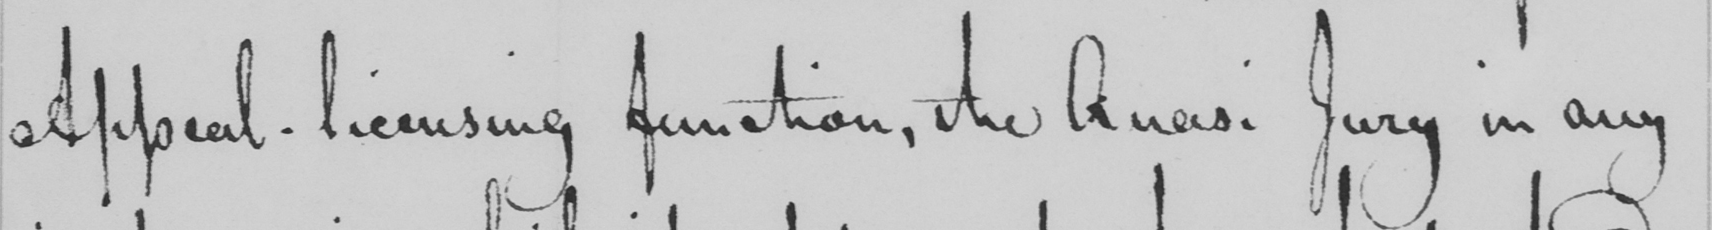What does this handwritten line say? Appeal - licensing function , the Quasi Jury in any 